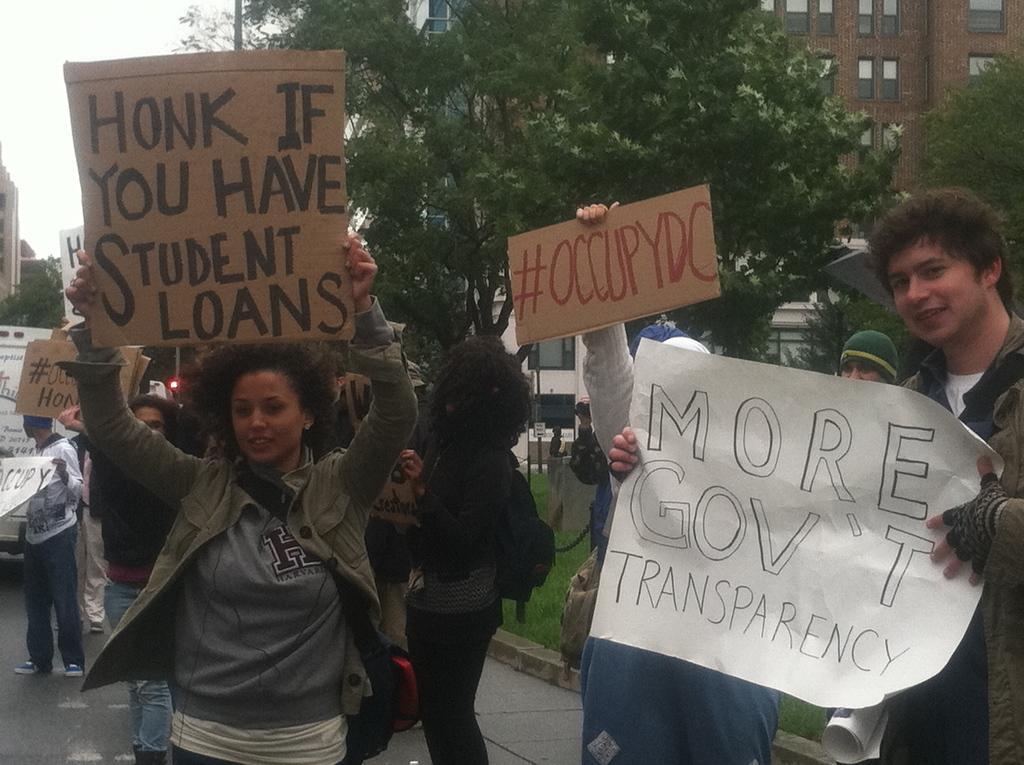Please provide a concise description of this image. In this image we can see many people and few people are holding objects in their hands. There are few boards and some text written on it in the image. There is a sky in the image. There is a grassy land in the image. There is a vehicle at the left side of the image. There are few buildings and they are having many windows in the image. 